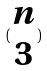<formula> <loc_0><loc_0><loc_500><loc_500>( \begin{matrix} n \\ 3 \end{matrix} )</formula> 